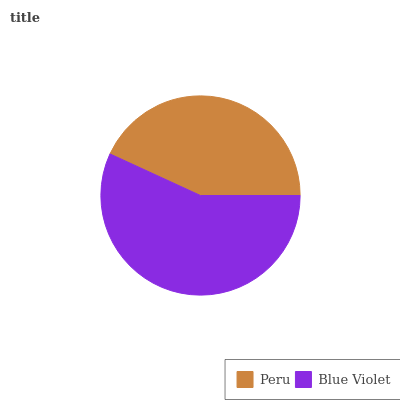Is Peru the minimum?
Answer yes or no. Yes. Is Blue Violet the maximum?
Answer yes or no. Yes. Is Blue Violet the minimum?
Answer yes or no. No. Is Blue Violet greater than Peru?
Answer yes or no. Yes. Is Peru less than Blue Violet?
Answer yes or no. Yes. Is Peru greater than Blue Violet?
Answer yes or no. No. Is Blue Violet less than Peru?
Answer yes or no. No. Is Blue Violet the high median?
Answer yes or no. Yes. Is Peru the low median?
Answer yes or no. Yes. Is Peru the high median?
Answer yes or no. No. Is Blue Violet the low median?
Answer yes or no. No. 